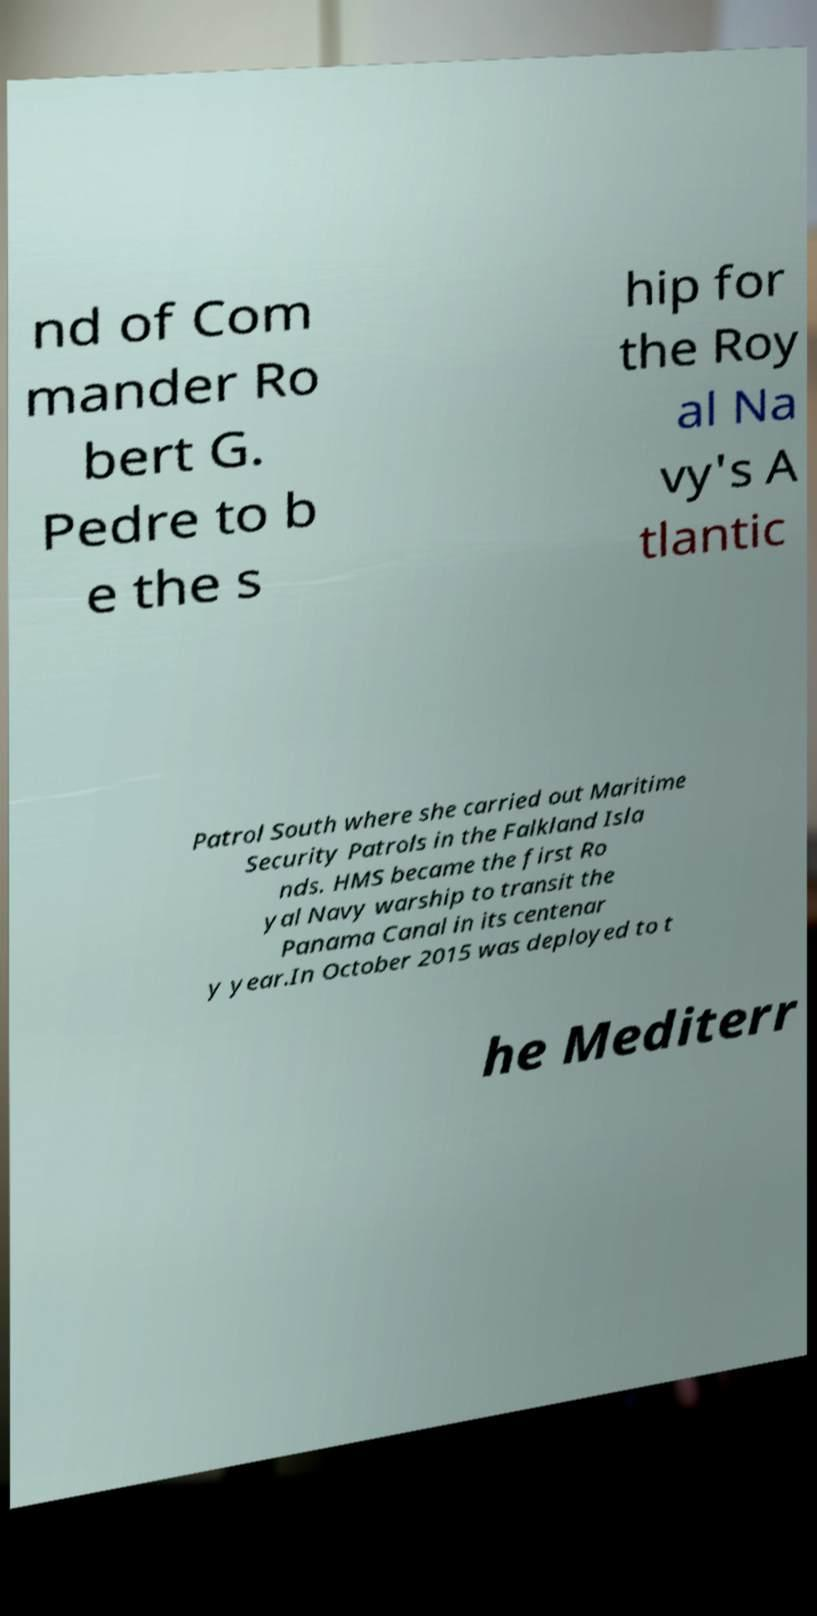Could you assist in decoding the text presented in this image and type it out clearly? nd of Com mander Ro bert G. Pedre to b e the s hip for the Roy al Na vy's A tlantic Patrol South where she carried out Maritime Security Patrols in the Falkland Isla nds. HMS became the first Ro yal Navy warship to transit the Panama Canal in its centenar y year.In October 2015 was deployed to t he Mediterr 